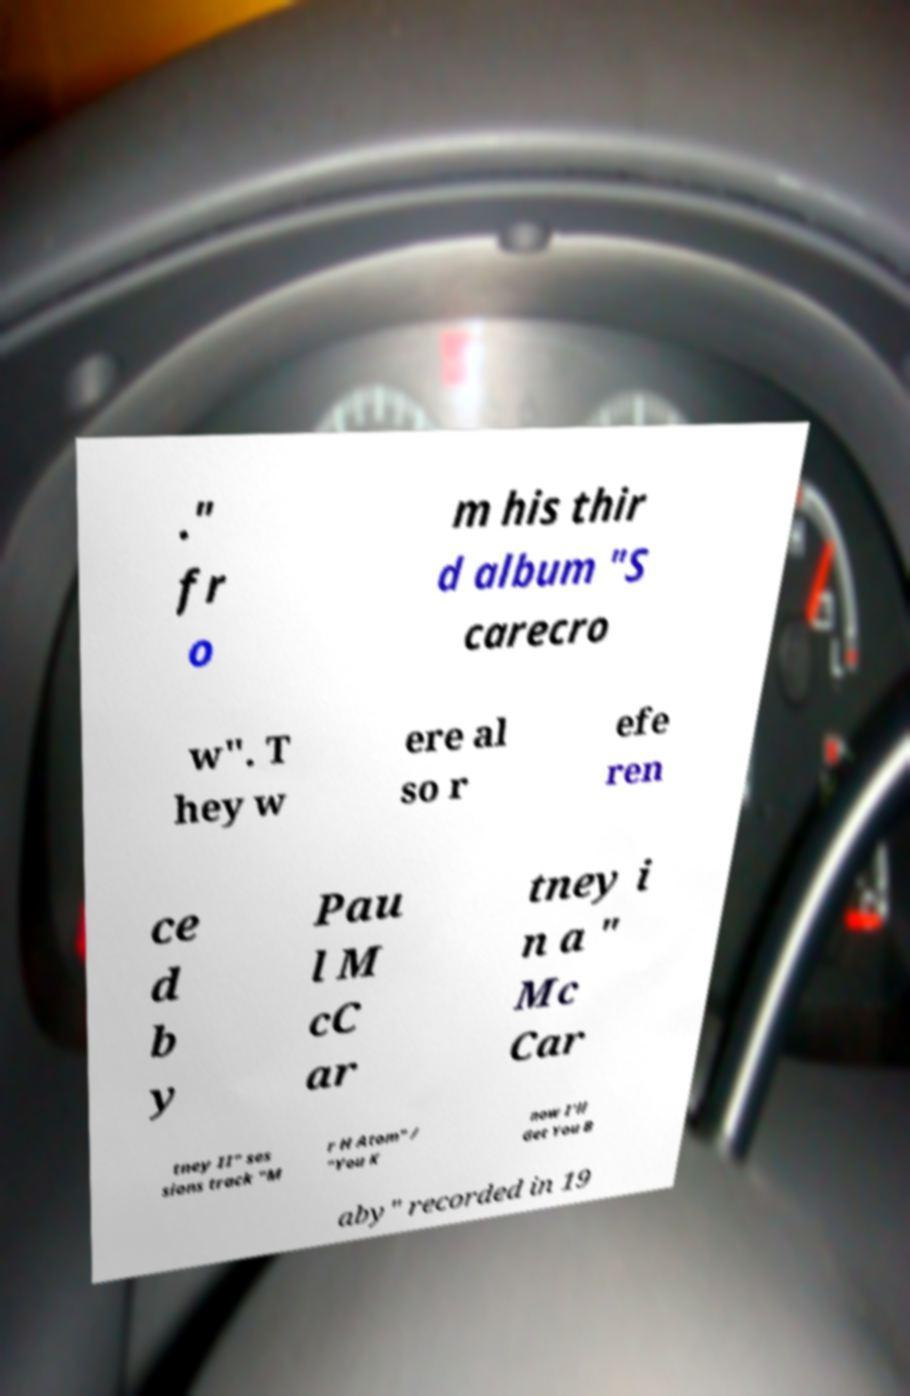Could you extract and type out the text from this image? ." fr o m his thir d album "S carecro w". T hey w ere al so r efe ren ce d b y Pau l M cC ar tney i n a " Mc Car tney II" ses sions track "M r H Atom" / "You K now I'll Get You B aby" recorded in 19 